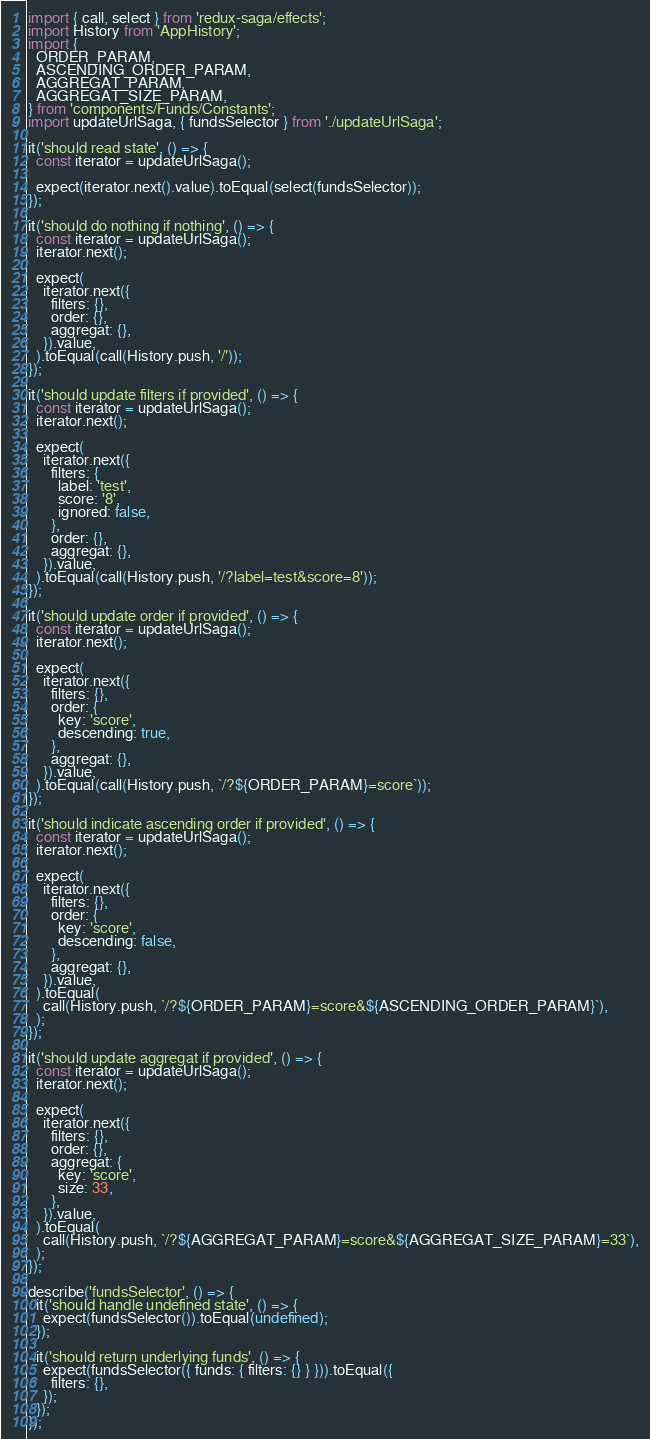<code> <loc_0><loc_0><loc_500><loc_500><_JavaScript_>import { call, select } from 'redux-saga/effects';
import History from 'AppHistory';
import {
  ORDER_PARAM,
  ASCENDING_ORDER_PARAM,
  AGGREGAT_PARAM,
  AGGREGAT_SIZE_PARAM,
} from 'components/Funds/Constants';
import updateUrlSaga, { fundsSelector } from './updateUrlSaga';

it('should read state', () => {
  const iterator = updateUrlSaga();

  expect(iterator.next().value).toEqual(select(fundsSelector));
});

it('should do nothing if nothing', () => {
  const iterator = updateUrlSaga();
  iterator.next();

  expect(
    iterator.next({
      filters: {},
      order: {},
      aggregat: {},
    }).value,
  ).toEqual(call(History.push, '/'));
});

it('should update filters if provided', () => {
  const iterator = updateUrlSaga();
  iterator.next();

  expect(
    iterator.next({
      filters: {
        label: 'test',
        score: '8',
        ignored: false,
      },
      order: {},
      aggregat: {},
    }).value,
  ).toEqual(call(History.push, '/?label=test&score=8'));
});

it('should update order if provided', () => {
  const iterator = updateUrlSaga();
  iterator.next();

  expect(
    iterator.next({
      filters: {},
      order: {
        key: 'score',
        descending: true,
      },
      aggregat: {},
    }).value,
  ).toEqual(call(History.push, `/?${ORDER_PARAM}=score`));
});

it('should indicate ascending order if provided', () => {
  const iterator = updateUrlSaga();
  iterator.next();

  expect(
    iterator.next({
      filters: {},
      order: {
        key: 'score',
        descending: false,
      },
      aggregat: {},
    }).value,
  ).toEqual(
    call(History.push, `/?${ORDER_PARAM}=score&${ASCENDING_ORDER_PARAM}`),
  );
});

it('should update aggregat if provided', () => {
  const iterator = updateUrlSaga();
  iterator.next();

  expect(
    iterator.next({
      filters: {},
      order: {},
      aggregat: {
        key: 'score',
        size: 33,
      },
    }).value,
  ).toEqual(
    call(History.push, `/?${AGGREGAT_PARAM}=score&${AGGREGAT_SIZE_PARAM}=33`),
  );
});

describe('fundsSelector', () => {
  it('should handle undefined state', () => {
    expect(fundsSelector()).toEqual(undefined);
  });

  it('should return underlying funds', () => {
    expect(fundsSelector({ funds: { filters: {} } })).toEqual({
      filters: {},
    });
  });
});
</code> 